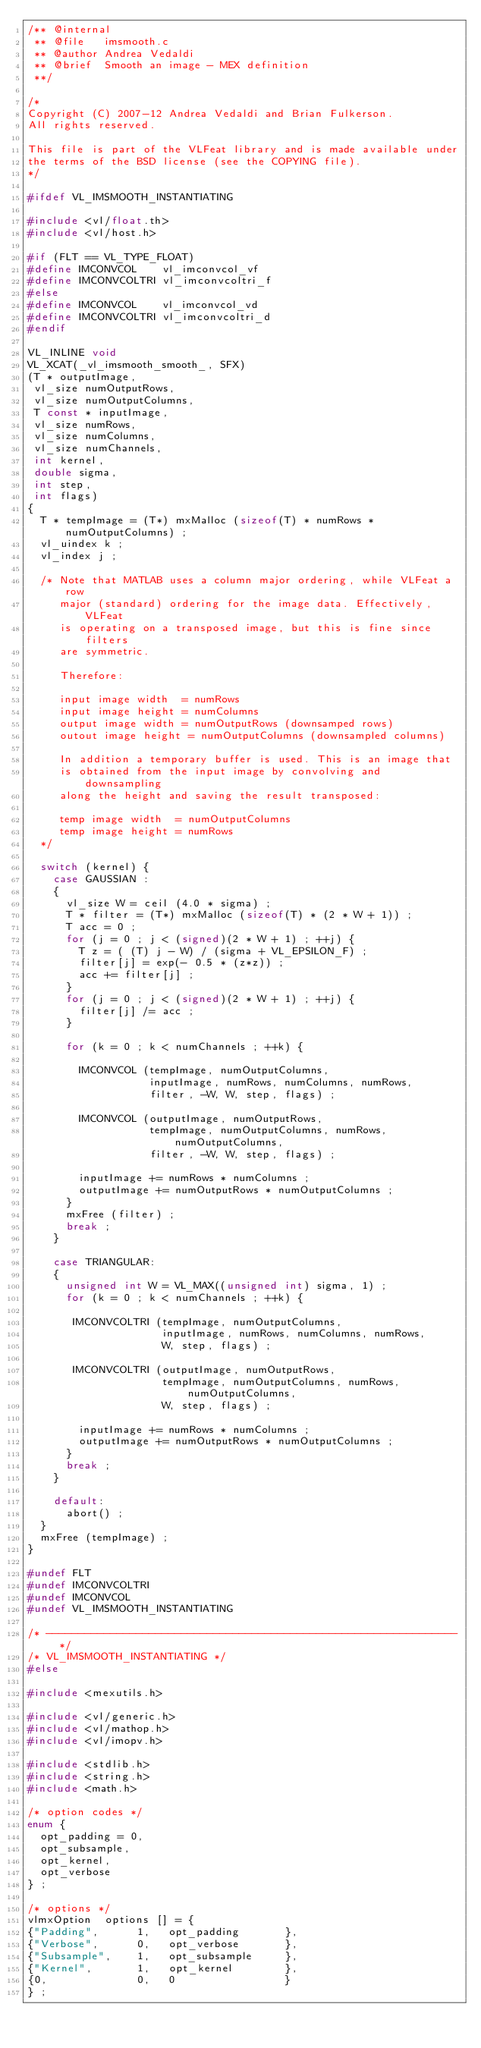<code> <loc_0><loc_0><loc_500><loc_500><_C_>/** @internal
 ** @file   imsmooth.c
 ** @author Andrea Vedaldi
 ** @brief  Smooth an image - MEX definition
 **/

/*
Copyright (C) 2007-12 Andrea Vedaldi and Brian Fulkerson.
All rights reserved.

This file is part of the VLFeat library and is made available under
the terms of the BSD license (see the COPYING file).
*/

#ifdef VL_IMSMOOTH_INSTANTIATING

#include <vl/float.th>
#include <vl/host.h>

#if (FLT == VL_TYPE_FLOAT)
#define IMCONVCOL    vl_imconvcol_vf
#define IMCONVCOLTRI vl_imconvcoltri_f
#else
#define IMCONVCOL    vl_imconvcol_vd
#define IMCONVCOLTRI vl_imconvcoltri_d
#endif

VL_INLINE void
VL_XCAT(_vl_imsmooth_smooth_, SFX)
(T * outputImage,
 vl_size numOutputRows,
 vl_size numOutputColumns,
 T const * inputImage,
 vl_size numRows,
 vl_size numColumns,
 vl_size numChannels,
 int kernel,
 double sigma,
 int step,
 int flags)
{
  T * tempImage = (T*) mxMalloc (sizeof(T) * numRows * numOutputColumns) ;
  vl_uindex k ;
  vl_index j ;

  /* Note that MATLAB uses a column major ordering, while VLFeat a row
     major (standard) ordering for the image data. Effectively, VLFeat
     is operating on a transposed image, but this is fine since filters
     are symmetric.

     Therefore:

     input image width  = numRows
     input image height = numColumns
     output image width = numOutputRows (downsamped rows)
     outout image height = numOutputColumns (downsampled columns)

     In addition a temporary buffer is used. This is an image that
     is obtained from the input image by convolving and downsampling
     along the height and saving the result transposed:

     temp image width  = numOutputColumns
     temp image height = numRows
  */

  switch (kernel) {
    case GAUSSIAN :
    {
      vl_size W = ceil (4.0 * sigma) ;
      T * filter = (T*) mxMalloc (sizeof(T) * (2 * W + 1)) ;
      T acc = 0 ;
      for (j = 0 ; j < (signed)(2 * W + 1) ; ++j) {
        T z = ( (T) j - W) / (sigma + VL_EPSILON_F) ;
        filter[j] = exp(- 0.5 * (z*z)) ;
        acc += filter[j] ;
      }
      for (j = 0 ; j < (signed)(2 * W + 1) ; ++j) {
        filter[j] /= acc ;
      }

      for (k = 0 ; k < numChannels ; ++k) {

        IMCONVCOL (tempImage, numOutputColumns,
                   inputImage, numRows, numColumns, numRows,
                   filter, -W, W, step, flags) ;

        IMCONVCOL (outputImage, numOutputRows,
                   tempImage, numOutputColumns, numRows, numOutputColumns,
                   filter, -W, W, step, flags) ;

        inputImage += numRows * numColumns ;
        outputImage += numOutputRows * numOutputColumns ;
      }
      mxFree (filter) ;
      break ;
    }

    case TRIANGULAR:
    {
      unsigned int W = VL_MAX((unsigned int) sigma, 1) ;
      for (k = 0 ; k < numChannels ; ++k) {

       IMCONVCOLTRI (tempImage, numOutputColumns,
                     inputImage, numRows, numColumns, numRows,
                     W, step, flags) ;

       IMCONVCOLTRI (outputImage, numOutputRows,
                     tempImage, numOutputColumns, numRows, numOutputColumns,
                     W, step, flags) ;

        inputImage += numRows * numColumns ;
        outputImage += numOutputRows * numOutputColumns ;
      }
      break ;
    }

    default:
      abort() ;
  }
  mxFree (tempImage) ;
}

#undef FLT
#undef IMCONVCOLTRI
#undef IMCONVCOL
#undef VL_IMSMOOTH_INSTANTIATING

/* ---------------------------------------------------------------- */
/* VL_IMSMOOTH_INSTANTIATING */
#else

#include <mexutils.h>

#include <vl/generic.h>
#include <vl/mathop.h>
#include <vl/imopv.h>

#include <stdlib.h>
#include <string.h>
#include <math.h>

/* option codes */
enum {
  opt_padding = 0,
  opt_subsample,
  opt_kernel,
  opt_verbose
} ;

/* options */
vlmxOption  options [] = {
{"Padding",      1,   opt_padding       },
{"Verbose",      0,   opt_verbose       },
{"Subsample",    1,   opt_subsample     },
{"Kernel",       1,   opt_kernel        },
{0,              0,   0                 }
} ;
</code> 